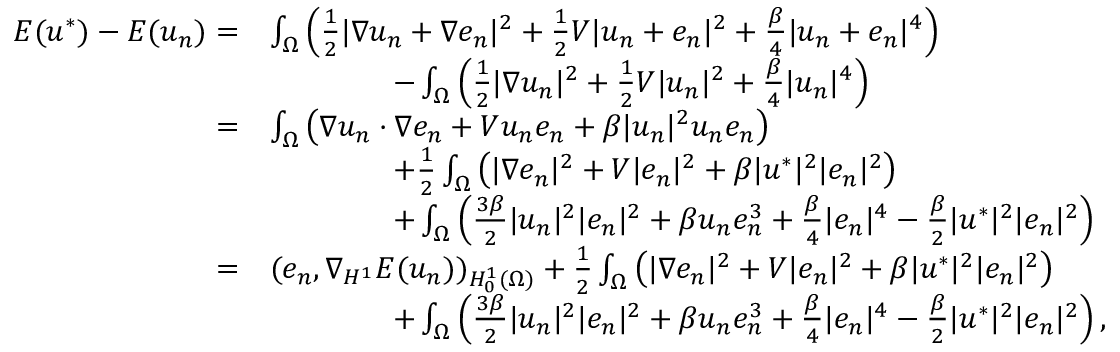<formula> <loc_0><loc_0><loc_500><loc_500>\begin{array} { r l } { E ( u ^ { * } ) - E ( u _ { n } ) = } & { \int _ { \Omega } \left ( \frac { 1 } { 2 } | \nabla u _ { n } + \nabla e _ { n } | ^ { 2 } + \frac { 1 } { 2 } V | u _ { n } + e _ { n } | ^ { 2 } + \frac { \beta } { 4 } | u _ { n } + e _ { n } | ^ { 4 } \right ) } \\ & { \quad - \int _ { \Omega } \left ( \frac { 1 } { 2 } | \nabla u _ { n } | ^ { 2 } + \frac { 1 } { 2 } V | u _ { n } | ^ { 2 } + \frac { \beta } { 4 } | u _ { n } | ^ { 4 } \right ) } \\ { = } & { \int _ { \Omega } \left ( \nabla u _ { n } \cdot \nabla e _ { n } + V u _ { n } e _ { n } + \beta | u _ { n } | ^ { 2 } u _ { n } e _ { n } \right ) } \\ & { \quad + \frac { 1 } { 2 } \int _ { \Omega } \left ( | \nabla e _ { n } | ^ { 2 } + V | e _ { n } | ^ { 2 } + \beta | u ^ { * } | ^ { 2 } | e _ { n } | ^ { 2 } \right ) } \\ & { \quad + \int _ { \Omega } \left ( \frac { 3 \beta } { 2 } | u _ { n } | ^ { 2 } | e _ { n } | ^ { 2 } + \beta u _ { n } e _ { n } ^ { 3 } + \frac { \beta } { 4 } | e _ { n } | ^ { 4 } - \frac { \beta } { 2 } | u ^ { * } | ^ { 2 } | e _ { n } | ^ { 2 } \right ) } \\ { = } & { ( e _ { n } , \nabla _ { H ^ { 1 } } E ( u _ { n } ) ) _ { H _ { 0 } ^ { 1 } ( \Omega ) } + \frac { 1 } { 2 } \int _ { \Omega } \left ( | \nabla e _ { n } | ^ { 2 } + V | e _ { n } | ^ { 2 } + \beta | u ^ { * } | ^ { 2 } | e _ { n } | ^ { 2 } \right ) } \\ & { \quad + \int _ { \Omega } \left ( \frac { 3 \beta } { 2 } | u _ { n } | ^ { 2 } | e _ { n } | ^ { 2 } + \beta u _ { n } e _ { n } ^ { 3 } + \frac { \beta } { 4 } | e _ { n } | ^ { 4 } - \frac { \beta } { 2 } | u ^ { * } | ^ { 2 } | e _ { n } | ^ { 2 } \right ) , } \end{array}</formula> 